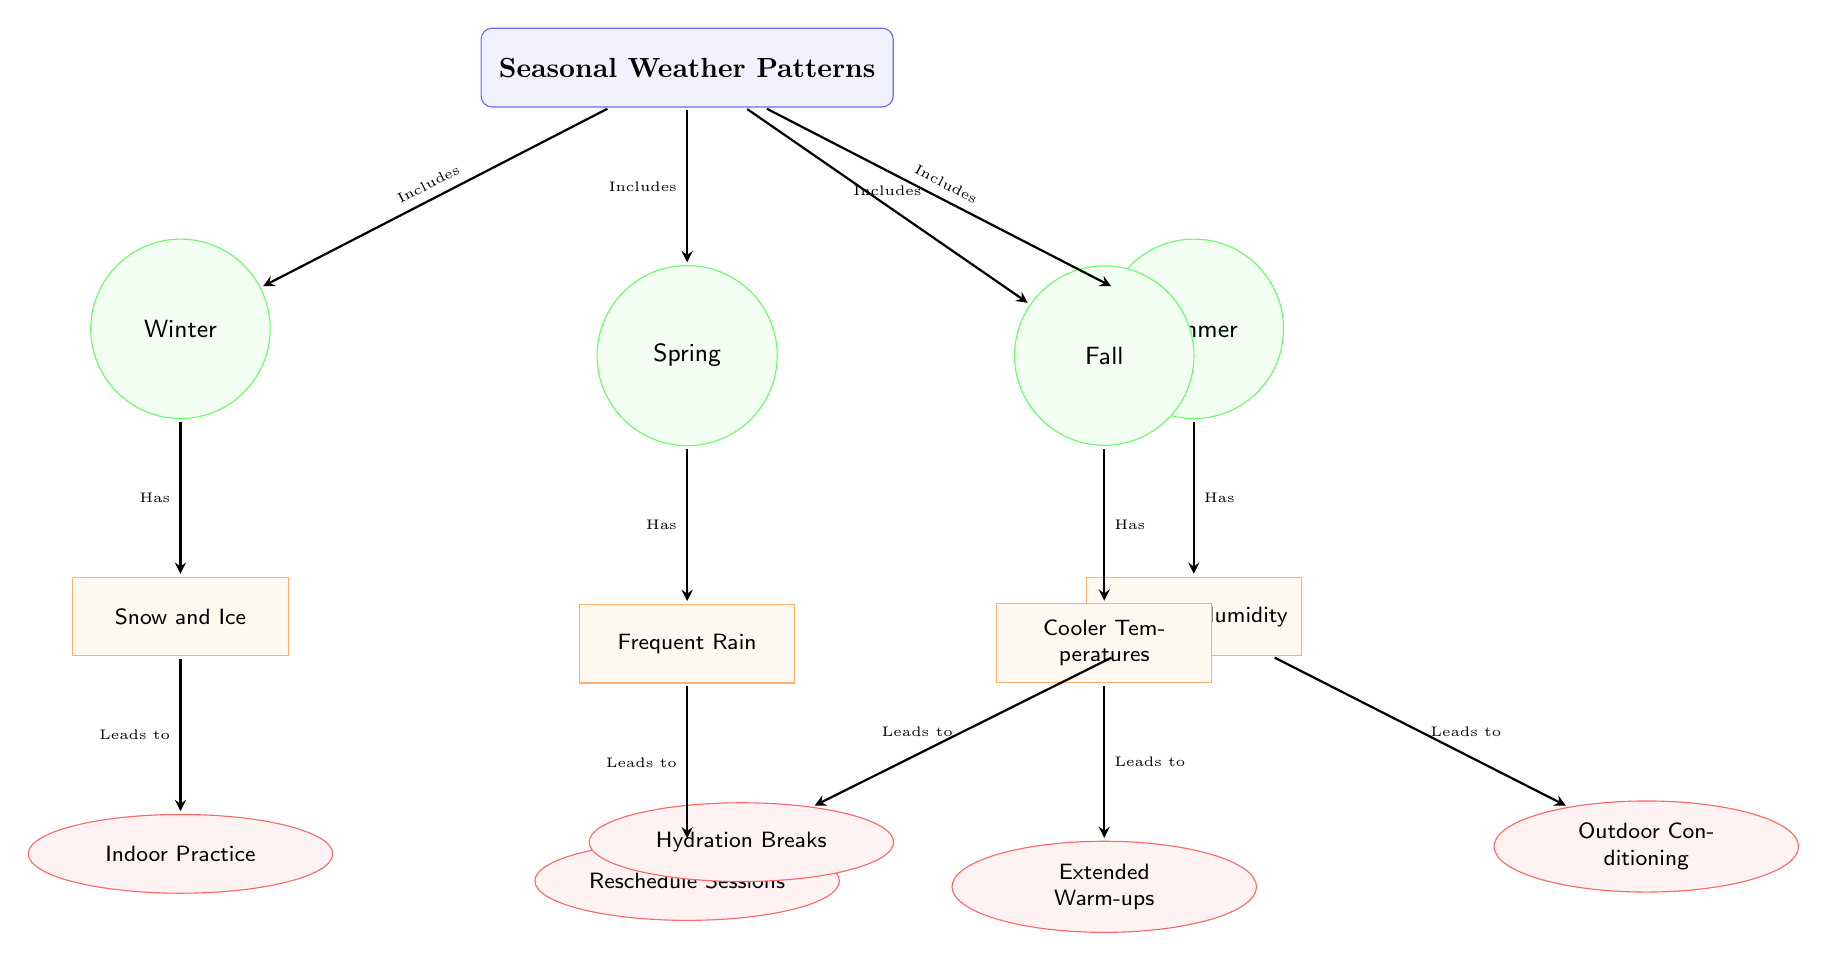What's the main subject of the diagram? The main subject is represented by the top node, labeled "Seasonal Weather Patterns," which encompasses all the subsequent elements related to seasonal changes and their effects on practice sessions.
Answer: Seasonal Weather Patterns How many seasons are represented in the diagram? There are four seasons in the diagram: Winter, Spring, Summer, and Fall, each represented as a distinct node.
Answer: Four What condition is associated with Summer? The condition associated with Summer is labeled "Heat and Humidity," which is shown as a node below the Summer season node.
Answer: Heat and Humidity What impact does snow lead to? The snow condition leads to the impact labeled "Indoor Practice," as shown by the connecting arrow pointing to this impact node from the snow condition node.
Answer: Indoor Practice Which season has the condition of "Frequent Rain"? The Spring season is linked to the condition labeled "Frequent Rain," as indicated by the connecting arrow from the Spring node to the rain condition node.
Answer: Spring What two impacts are associated with the heat condition? The heat condition leads to two impacts: "Hydration Breaks" and "Outdoor Conditioning," which are illustrated as nodes below the heat condition node.
Answer: Hydration Breaks and Outdoor Conditioning How does the Fall season affect practice sessions? The Fall season is linked to the condition "Cooler Temperatures," and this condition impacts practice sessions by leading to "Extended Warm-ups," as indicated by the arrows in the diagram.
Answer: Extended Warm-ups Which season includes snow as a condition? Winter includes snow as a condition, as indicated by the direct relationship from the Winter node to the snow condition node.
Answer: Winter What type of diagram is this? This is a Textbook Diagram, which typically organizes information about a concept into structured relationships, guiding the viewer through connections and impacts.
Answer: Textbook Diagram 